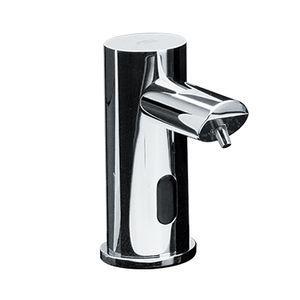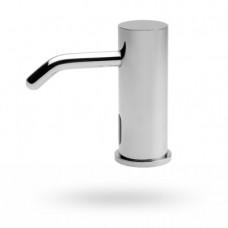The first image is the image on the left, the second image is the image on the right. Given the left and right images, does the statement "The left and right image contains the same number of sink soap dispensers." hold true? Answer yes or no. Yes. The first image is the image on the left, the second image is the image on the right. Considering the images on both sides, is "There is one dispenser attached to a plastic bottle." valid? Answer yes or no. No. 